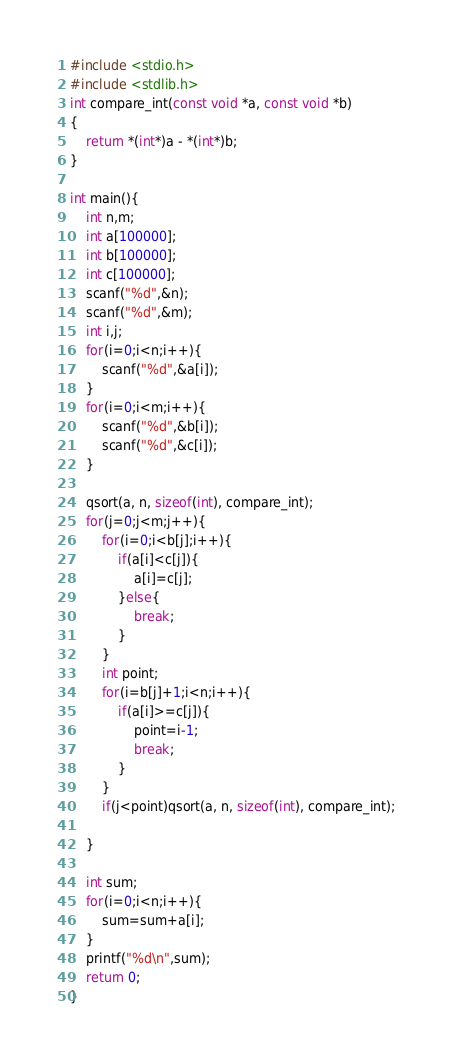Convert code to text. <code><loc_0><loc_0><loc_500><loc_500><_C++_>#include <stdio.h>
#include <stdlib.h>
int compare_int(const void *a, const void *b)
{
    return *(int*)a - *(int*)b;
}

int main(){
    int n,m;
    int a[100000];
    int b[100000];
    int c[100000];
    scanf("%d",&n);
    scanf("%d",&m);
    int i,j;
    for(i=0;i<n;i++){
        scanf("%d",&a[i]);
    }
    for(i=0;i<m;i++){
        scanf("%d",&b[i]);
        scanf("%d",&c[i]);
    }

    qsort(a, n, sizeof(int), compare_int);
    for(j=0;j<m;j++){
        for(i=0;i<b[j];i++){
            if(a[i]<c[j]){
                a[i]=c[j];
            }else{
                break;
            }
        }
        int point;
        for(i=b[j]+1;i<n;i++){
            if(a[i]>=c[j]){
                point=i-1;
                break;
            }
        }
        if(j<point)qsort(a, n, sizeof(int), compare_int);

    }

    int sum;
    for(i=0;i<n;i++){
        sum=sum+a[i];
    }
    printf("%d\n",sum);
    return 0;
}
</code> 